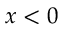Convert formula to latex. <formula><loc_0><loc_0><loc_500><loc_500>x < 0</formula> 